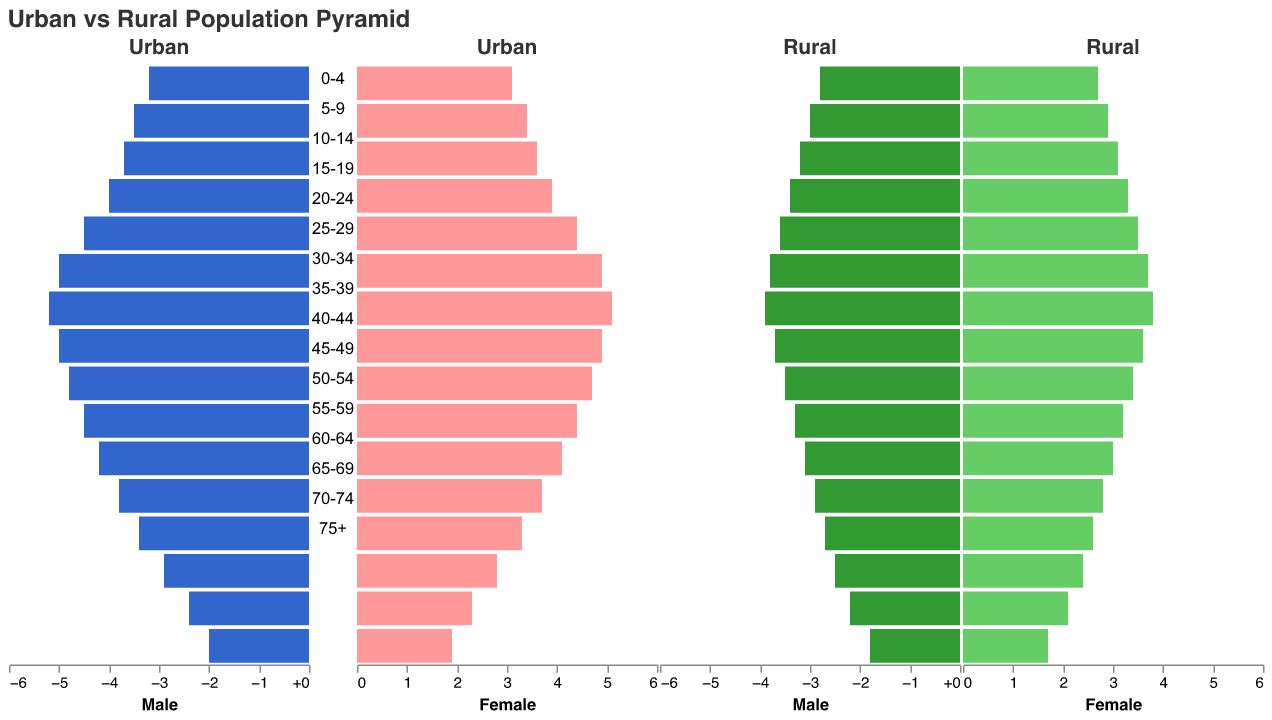What is the trend for the population of urban males as the age group increases? The population of urban males increases gradually from age group 0-4 to 30-34, peaks at age group 30-34, and then starts to decline.
Answer: Increases to a peak at 30-34, then declines How does the rural female population in the age group 20-24 compare to the urban female population in the same age group? The rural female population in the age group 20-24 is represented at 3.5%, while the urban female population in the same age group is represented at 4.4%. Comparing these, the urban female population is higher.
Answer: Urban female population is higher Which age group has the highest urban male population? By examining the data plotted, we see that the age group 30-34 has the highest proportion of urban males at 5.2%.
Answer: 30-34 What is the difference in population between rural males and rural females in the age group 55-59? The rural male population in age group 55-59 is 2.9%, and the rural female population is 2.8%. The difference is calculated as 2.9% - 2.8% = 0.1%.
Answer: 0.1% How does the urban population in age group 40-44 compare between males and females? For age group 40-44, the urban male population is shown at 4.8%, and the urban female population is shown at 4.7%. The difference is 4.8% - 4.7% = 0.1%, so males slightly outnumber females.
Answer: Males slightly outnumber females by 0.1% Considering both urban and rural areas, in which age group is the female population the highest? The highest percentage for females in both urban and rural areas is in the age group 30-34, with urban females at 5.1% and rural females at 3.8%. Thus, the urban female population is the highest in the age group 30-34.
Answer: 30-34 What is the combined population percentage of rural males and females in the age group 65-69? The rural male population in age group 65-69 is 2.5%, and the rural female population is 2.4%. The combined population is 2.5% + 2.4% = 4.9%.
Answer: 4.9% Compare the population pyramids of urban and rural areas: which type of area shows a more balanced population distribution between males and females? By comparing the bar lengths for males and females in each age group for both urban and rural areas, it is apparent that the urban areas show more balance. The difference in bar lengths is generally less pronounced in urban areas than in rural areas.
Answer: Urban areas How does the population percentage of urban males and females in the age group 50-54 compare to the rural males and females in the same group? For age group 50-54, the urban male population is 4.2% and the urban female population is 4.1%. For rural males, the population is 3.1%, and for rural females, it is 3.0%. Urban populations for both males and females are higher than their rural counterparts.
Answer: Urban populations are higher What can we infer about the economic development needs based on the population distribution in age groups 20-34 in urban vs rural areas? The age groups 20-34 have higher percentages in urban areas compared to rural areas. This indicates a higher concentration of working-age individuals in urban areas, implying a need for more employment opportunities, infrastructure, and services to support an active workforce in urban regions, while rural areas may require development policies focusing on retaining and attracting younger populations.
Answer: Urban areas need more employment opportunities and services 